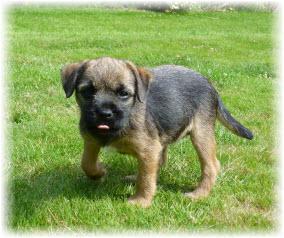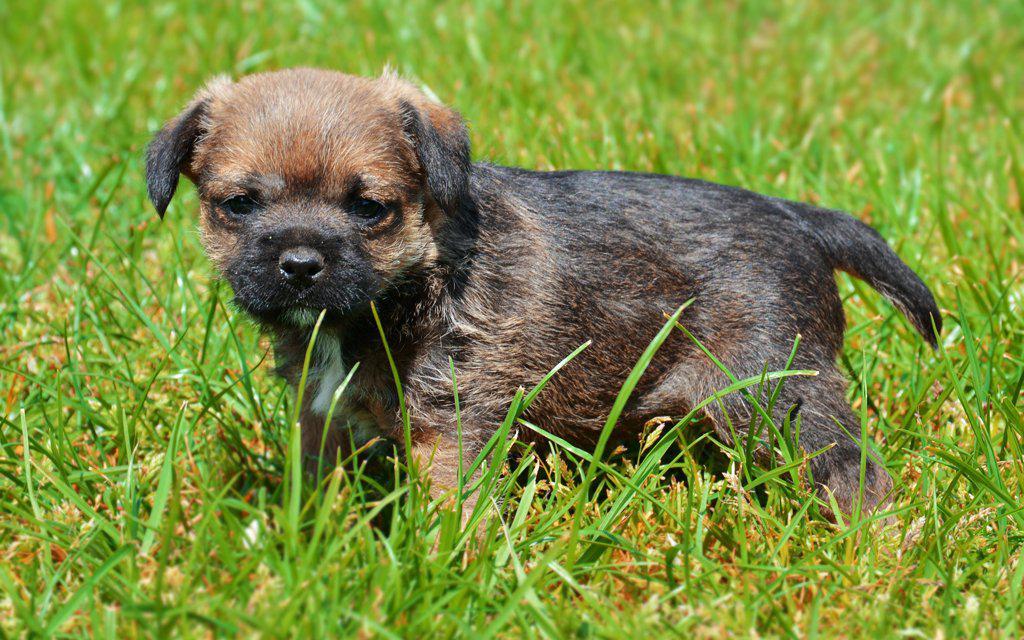The first image is the image on the left, the second image is the image on the right. Evaluate the accuracy of this statement regarding the images: "One of the dogs is wearing something colorful around its neck area.". Is it true? Answer yes or no. No. 